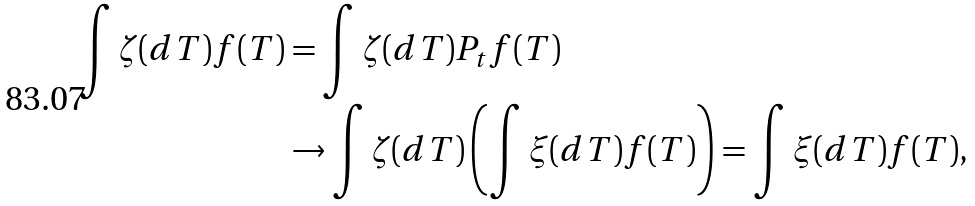Convert formula to latex. <formula><loc_0><loc_0><loc_500><loc_500>\int \zeta ( d T ) f ( T ) & = \int \zeta ( d T ) P _ { t } f ( T ) \\ & \rightarrow \int \zeta ( d T ) \left ( \int \xi ( d T ) f ( T ) \right ) = \int \xi ( d T ) f ( T ) , \\</formula> 